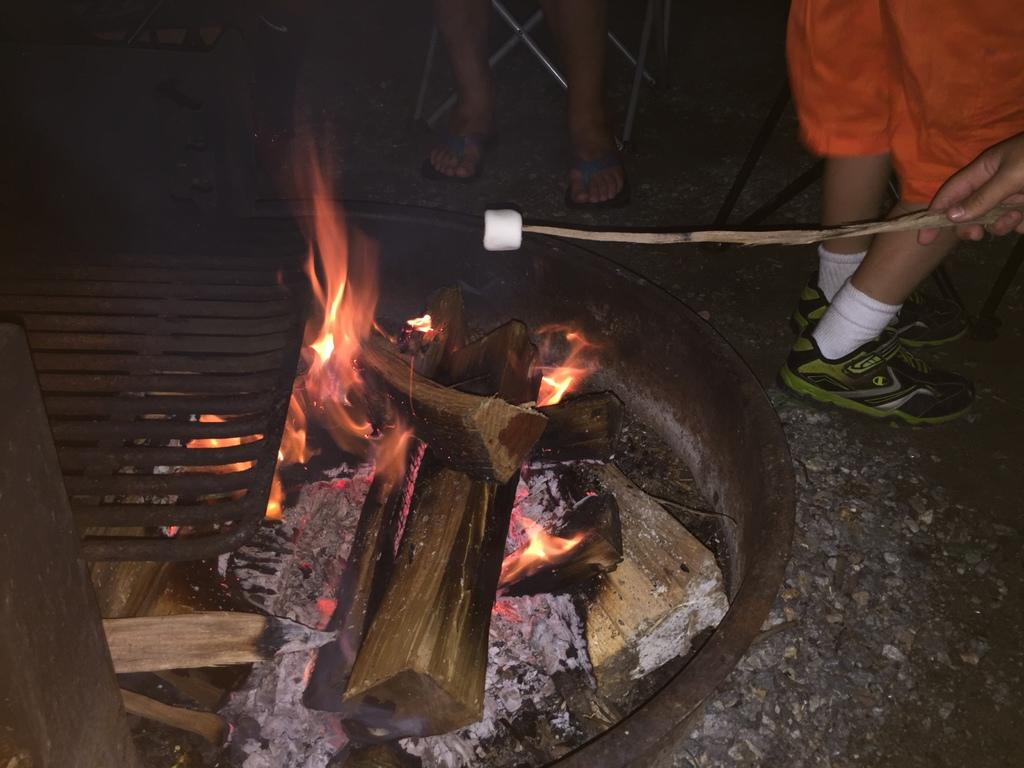What are the persons in the image doing? The persons in the image are standing on the ground. Can you describe what one of the persons is holding? One of the persons is holding a stick. What is attached to the stick? Food is attached to the stick. Where is the stick positioned in relation to the campfire? The stick is above the campfire. Can you tell me how many crowns are visible in the image? There are no crowns present in the image. What direction are the persons turning in the image? The persons are not turning in the image; they are standing still. 